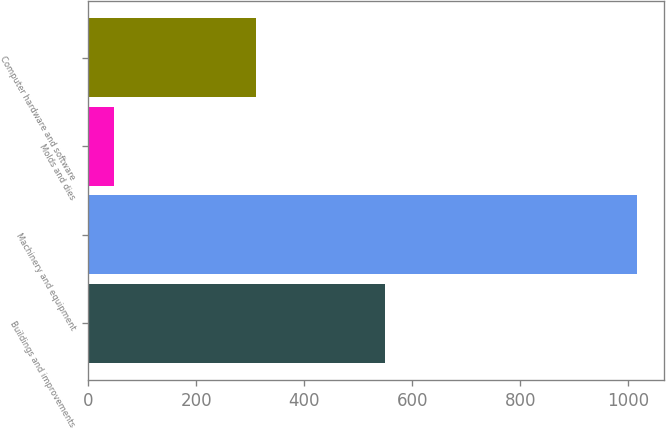Convert chart. <chart><loc_0><loc_0><loc_500><loc_500><bar_chart><fcel>Buildings and improvements<fcel>Machinery and equipment<fcel>Molds and dies<fcel>Computer hardware and software<nl><fcel>550<fcel>1015<fcel>47<fcel>310<nl></chart> 